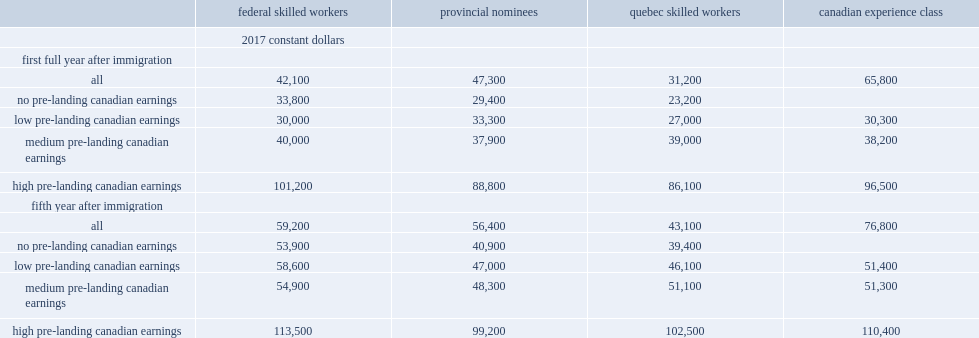What percentages did cec immigrants earned more than fswp immigrants in the first full year and fifth year respectively? 0.562945 0.297297. Who had lower earnings in the fifth year after immigration,pnp immigrants or fswp immigrants. Provincial nominees. Who had the lowest earnings in the first year and fifth year after immigration respectively? Quebec skilled workers. 